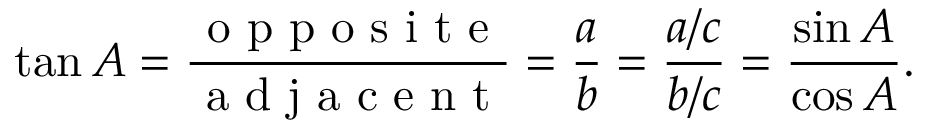Convert formula to latex. <formula><loc_0><loc_0><loc_500><loc_500>\tan A = { \frac { o p p o s i t e } { a d j a c e n t } } = { \frac { a } { b } } = { \frac { a / c } { b / c } } = { \frac { \sin A } { \cos A } } .</formula> 